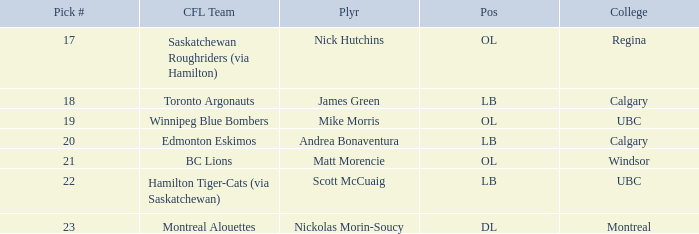What number picks were the players who went to Calgary?  18, 20. 